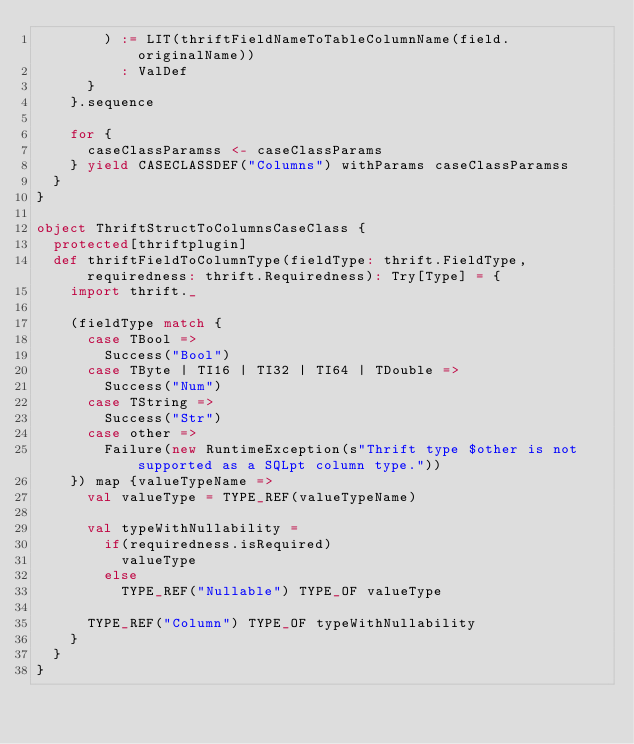Convert code to text. <code><loc_0><loc_0><loc_500><loc_500><_Scala_>        ) := LIT(thriftFieldNameToTableColumnName(field.originalName))
          : ValDef
      }
    }.sequence

    for {
      caseClassParamss <- caseClassParams
    } yield CASECLASSDEF("Columns") withParams caseClassParamss
  }
}

object ThriftStructToColumnsCaseClass {
  protected[thriftplugin]
  def thriftFieldToColumnType(fieldType: thrift.FieldType, requiredness: thrift.Requiredness): Try[Type] = {
    import thrift._

    (fieldType match {
      case TBool =>
        Success("Bool")
      case TByte | TI16 | TI32 | TI64 | TDouble =>
        Success("Num")
      case TString =>
        Success("Str")
      case other =>
        Failure(new RuntimeException(s"Thrift type $other is not supported as a SQLpt column type."))
    }) map {valueTypeName =>
      val valueType = TYPE_REF(valueTypeName)

      val typeWithNullability =
        if(requiredness.isRequired)
          valueType
        else
          TYPE_REF("Nullable") TYPE_OF valueType

      TYPE_REF("Column") TYPE_OF typeWithNullability
    }
  }
}</code> 